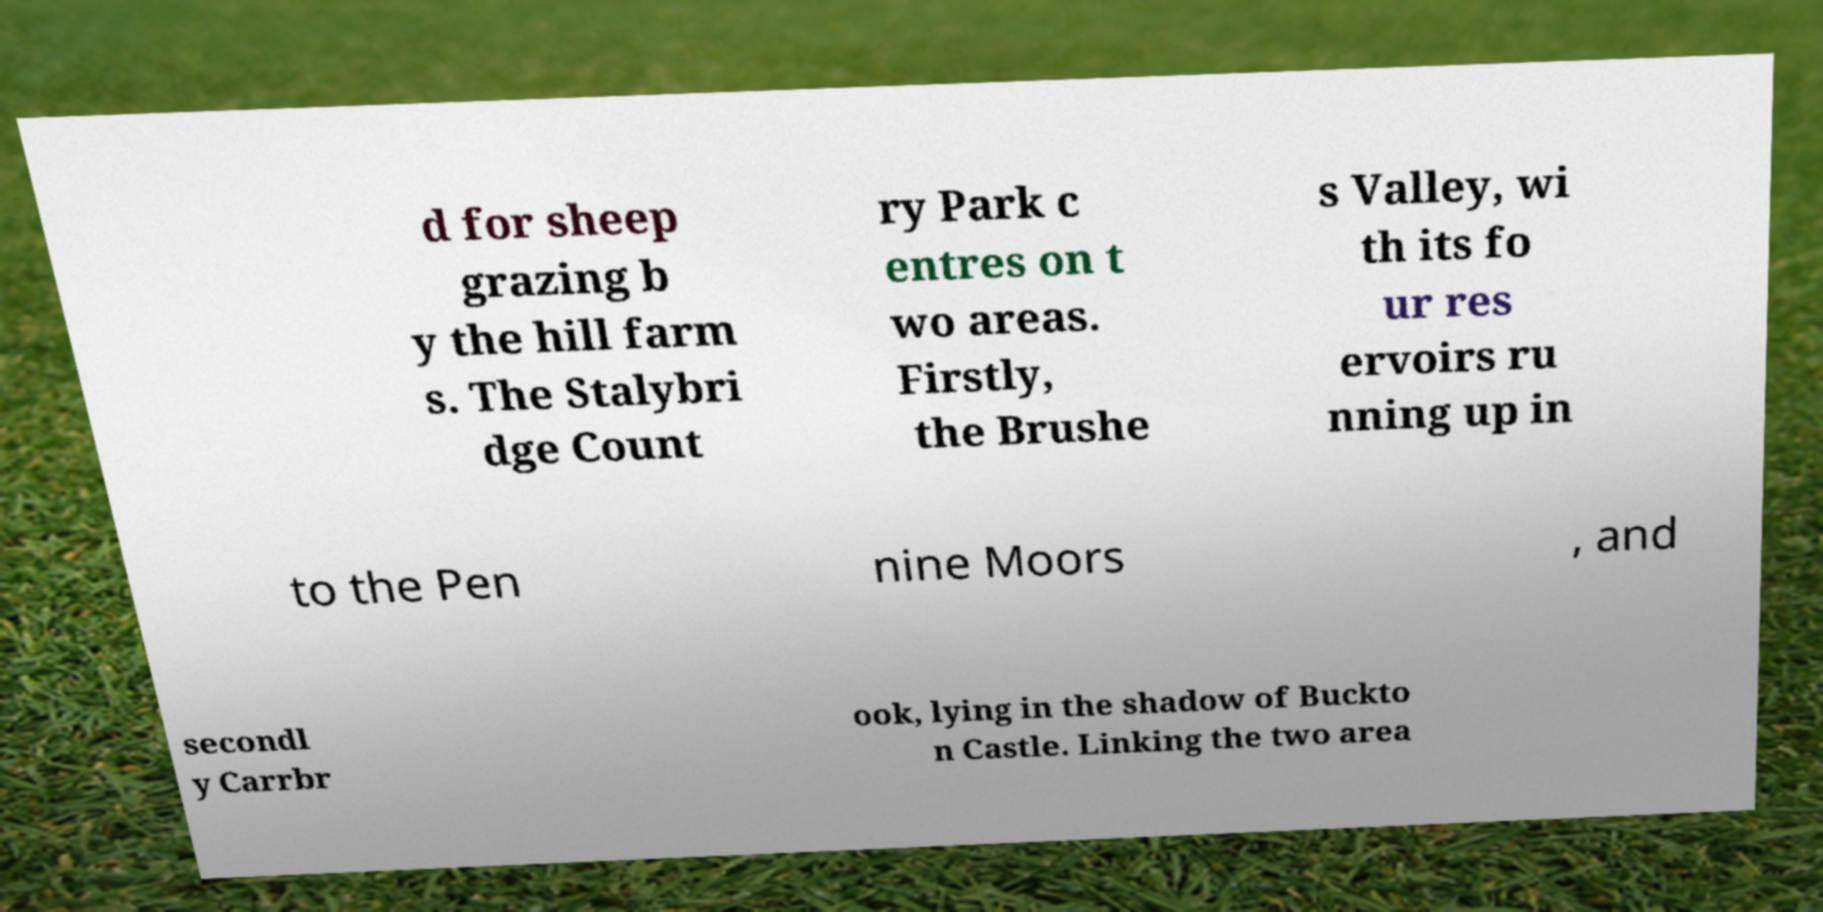Can you accurately transcribe the text from the provided image for me? d for sheep grazing b y the hill farm s. The Stalybri dge Count ry Park c entres on t wo areas. Firstly, the Brushe s Valley, wi th its fo ur res ervoirs ru nning up in to the Pen nine Moors , and secondl y Carrbr ook, lying in the shadow of Buckto n Castle. Linking the two area 